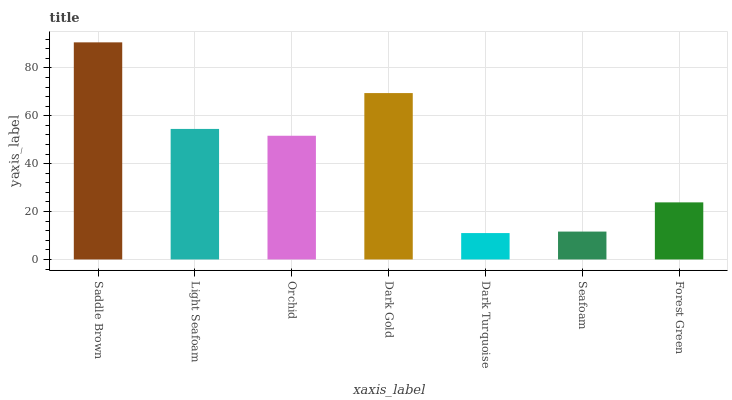Is Dark Turquoise the minimum?
Answer yes or no. Yes. Is Saddle Brown the maximum?
Answer yes or no. Yes. Is Light Seafoam the minimum?
Answer yes or no. No. Is Light Seafoam the maximum?
Answer yes or no. No. Is Saddle Brown greater than Light Seafoam?
Answer yes or no. Yes. Is Light Seafoam less than Saddle Brown?
Answer yes or no. Yes. Is Light Seafoam greater than Saddle Brown?
Answer yes or no. No. Is Saddle Brown less than Light Seafoam?
Answer yes or no. No. Is Orchid the high median?
Answer yes or no. Yes. Is Orchid the low median?
Answer yes or no. Yes. Is Seafoam the high median?
Answer yes or no. No. Is Seafoam the low median?
Answer yes or no. No. 